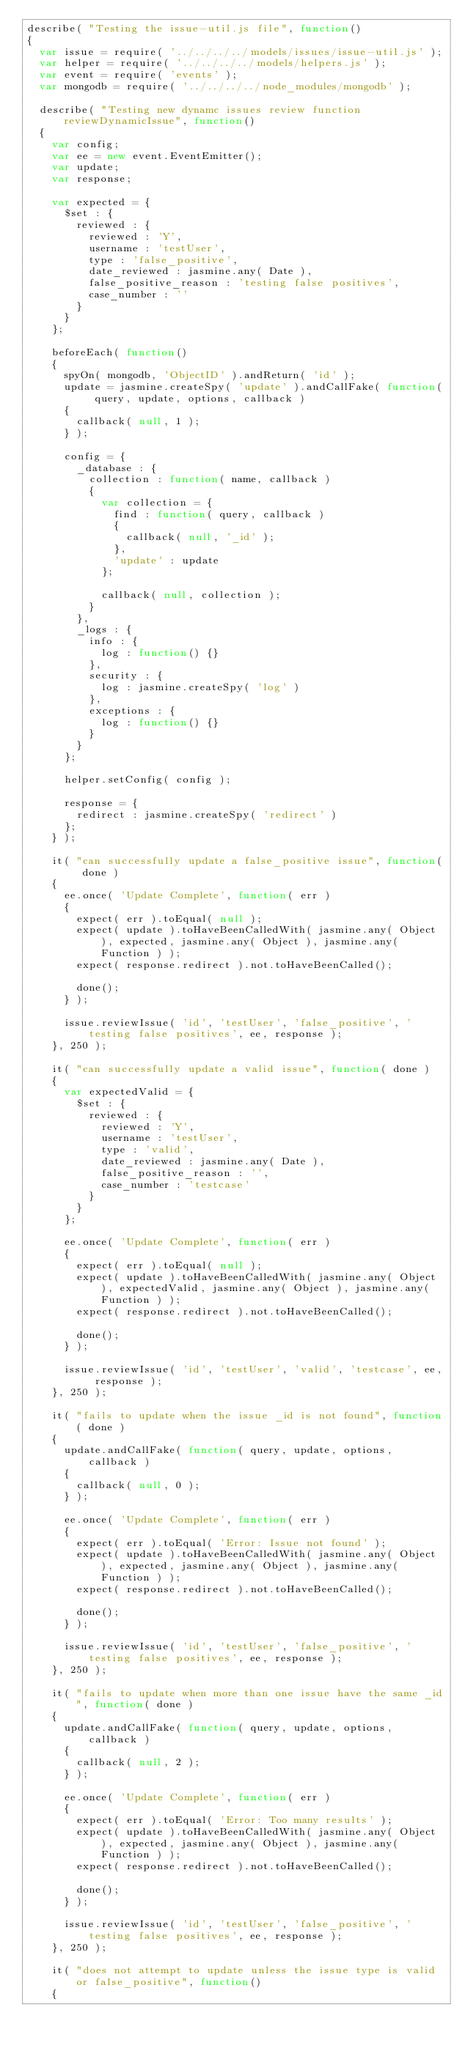<code> <loc_0><loc_0><loc_500><loc_500><_JavaScript_>describe( "Testing the issue-util.js file", function()
{
  var issue = require( '../../../../models/issues/issue-util.js' );
  var helper = require( '../../../../models/helpers.js' );
  var event = require( 'events' );
  var mongodb = require( '../../../../node_modules/mongodb' );
  
  describe( "Testing new dynamc issues review function reviewDynamicIssue", function()
  {
    var config;
    var ee = new event.EventEmitter();
    var update;
    var response;
    
    var expected = {
      $set : {
        reviewed : {
          reviewed : 'Y',
          username : 'testUser', 
          type : 'false_positive',
          date_reviewed : jasmine.any( Date ),
          false_positive_reason : 'testing false positives',
          case_number : ''
        }
      }
    };
    
    beforeEach( function()
    {
      spyOn( mongodb, 'ObjectID' ).andReturn( 'id' );
      update = jasmine.createSpy( 'update' ).andCallFake( function( query, update, options, callback )
      {
        callback( null, 1 );
      } );
      
      config = {
        _database : {
          collection : function( name, callback )
          {
            var collection = {
              find : function( query, callback )
              {
                callback( null, '_id' );
              },
              'update' : update 
            };
            
            callback( null, collection );
          }
        },
        _logs : {
          info : {
            log : function() {}
          },
          security : {
            log : jasmine.createSpy( 'log' )
          },
          exceptions : {
            log : function() {}
          }
        }
      };
      
      helper.setConfig( config );
      
      response = {
        redirect : jasmine.createSpy( 'redirect' )
      }; 
    } );
    
    it( "can successfully update a false_positive issue", function( done )
    {
      ee.once( 'Update Complete', function( err )
      {
        expect( err ).toEqual( null );
        expect( update ).toHaveBeenCalledWith( jasmine.any( Object ), expected, jasmine.any( Object ), jasmine.any( Function ) );
        expect( response.redirect ).not.toHaveBeenCalled();
        
        done();
      } );
      
      issue.reviewIssue( 'id', 'testUser', 'false_positive', 'testing false positives', ee, response );
    }, 250 );
    
    it( "can successfully update a valid issue", function( done )
    {
      var expectedValid = {
        $set : {
          reviewed : {
            reviewed : 'Y',
            username : 'testUser', 
            type : 'valid',
            date_reviewed : jasmine.any( Date ),
            false_positive_reason : '',
            case_number : 'testcase'
          }
        }
      };
      
      ee.once( 'Update Complete', function( err )
      {
        expect( err ).toEqual( null );
        expect( update ).toHaveBeenCalledWith( jasmine.any( Object ), expectedValid, jasmine.any( Object ), jasmine.any( Function ) );
        expect( response.redirect ).not.toHaveBeenCalled();
        
        done();
      } );
      
      issue.reviewIssue( 'id', 'testUser', 'valid', 'testcase', ee, response );
    }, 250 );
    
    it( "fails to update when the issue _id is not found", function( done )
    {
      update.andCallFake( function( query, update, options, callback )
      {
        callback( null, 0 );
      } );
      
      ee.once( 'Update Complete', function( err )
      {
        expect( err ).toEqual( 'Error: Issue not found' );
        expect( update ).toHaveBeenCalledWith( jasmine.any( Object ), expected, jasmine.any( Object ), jasmine.any( Function ) );
        expect( response.redirect ).not.toHaveBeenCalled();
        
        done();
      } );
      
      issue.reviewIssue( 'id', 'testUser', 'false_positive', 'testing false positives', ee, response );
    }, 250 );
    
    it( "fails to update when more than one issue have the same _id", function( done )
    {
      update.andCallFake( function( query, update, options, callback )
      {
        callback( null, 2 );
      } );
      
      ee.once( 'Update Complete', function( err )
      {
        expect( err ).toEqual( 'Error: Too many results' );
        expect( update ).toHaveBeenCalledWith( jasmine.any( Object ), expected, jasmine.any( Object ), jasmine.any( Function ) );
        expect( response.redirect ).not.toHaveBeenCalled();
        
        done();
      } );
      
      issue.reviewIssue( 'id', 'testUser', 'false_positive', 'testing false positives', ee, response );
    }, 250 );
    
    it( "does not attempt to update unless the issue type is valid or false_positive", function()
    {</code> 